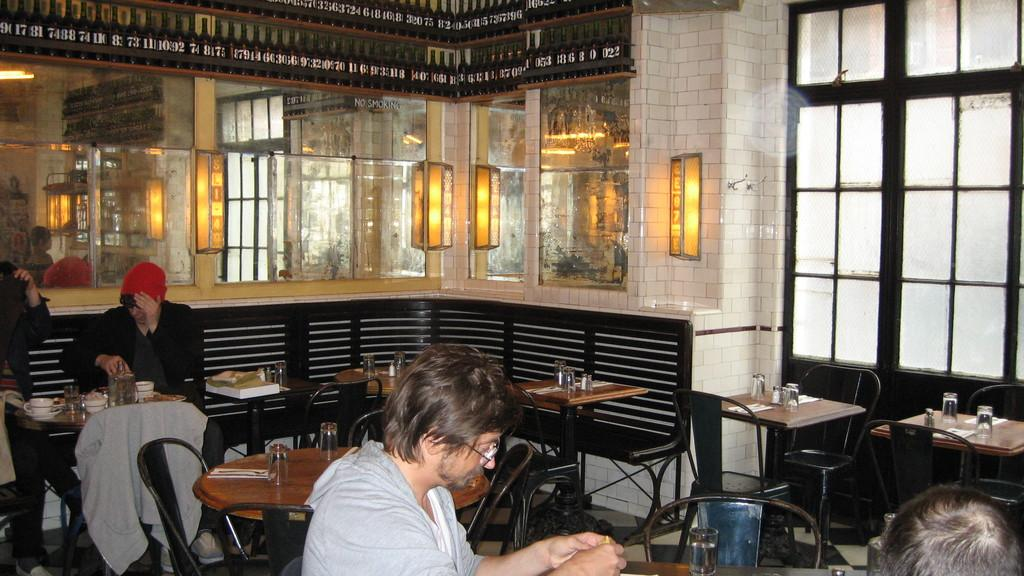What are the people in the image doing? The people in the image are sitting on chairs and having food. Can you describe the lighting in the image? There is a lamp in the middle of the image, which provides light. What is the reason behind the people in the image not having any drinks with their food? The provided facts do not mention anything about drinks, so we cannot determine if the people have any drinks or the reason behind it. 